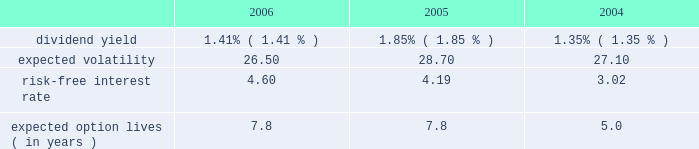For the year ended december 31 , 2005 , we realized net losses of $ 1 million on sales of available-for- sale securities .
Unrealized gains of $ 1 million were included in other comprehensive income at december 31 , 2004 , net of deferred taxes of less than $ 1 million , related to these sales .
For the year ended december 31 , 2004 , we realized net gains of $ 26 million on sales of available-for- sale securities .
Unrealized gains of $ 11 million were included in other comprehensive income at december 31 , 2003 , net of deferred taxes of $ 7 million , related to these sales .
Note 13 .
Equity-based compensation the 2006 equity incentive plan was approved by shareholders in april 2006 , and 20000000 shares of common stock were approved for issuance for stock and stock-based awards , including stock options , stock appreciation rights , restricted stock , deferred stock and performance awards .
In addition , up to 8000000 shares from our 1997 equity incentive plan , that were available to issue or become available due to cancellations and forfeitures , may be awarded under the 2006 plan .
The 1997 plan expired on december 18 , 2006 .
As of december 31 , 2006 , 1305420 shares from the 1997 plan have been added to and may be awarded from the 2006 plan .
As of december 31 , 2006 , 106045 awards have been made under the 2006 plan .
We have stock options outstanding from previous plans , including the 1997 plan , under which no further grants can be made .
The exercise price of non-qualified and incentive stock options and stock appreciation rights may not be less than the fair value of such shares at the date of grant .
Stock options and stock appreciation rights issued under the 2006 plan and the prior 1997 plan generally vest over four years and expire no later than ten years from the date of grant .
For restricted stock awards issued under the 2006 plan and the prior 1997 plan , stock certificates are issued at the time of grant and recipients have dividend and voting rights .
In general , these grants vest over three years .
For deferred stock awards issued under the 2006 plan and the prior 1997 plan , no stock is issued at the time of grant .
Generally , these grants vest over two- , three- or four-year periods .
Performance awards granted under the 2006 equity incentive plan and the prior 1997 plan are earned over a performance period based on achievement of goals , generally over two- to three- year periods .
Payment for performance awards is made in shares of our common stock or in cash equal to the fair market value of our common stock , based on certain financial ratios after the conclusion of each performance period .
We record compensation expense , equal to the estimated fair value of the options on the grant date , on a straight-line basis over the options 2019 vesting period .
We use a black-scholes option-pricing model to estimate the fair value of the options granted .
The weighted-average assumptions used in connection with the option-pricing model were as follows for the years indicated. .
Compensation expense related to stock options , stock appreciation rights , restricted stock awards , deferred stock awards and performance awards , which we record as a component of salaries and employee benefits expense in our consolidated statement of income , was $ 208 million , $ 110 million and $ 74 million for the years ended december 31 , 2006 , 2005 and 2004 , respectively .
The related total income tax benefit recorded in our consolidated statement of income was $ 83 million , $ 44 million and $ 30 million for 2006 , 2005 and 2004 , respectively .
Seq 87 copyarea : 38 .
X 54 .
Trimsize : 8.25 x 10.75 typeset state street corporation serverprocess c:\\fc\\delivery_1024177\\2771-1-do_p.pdf chksum : 0 cycle 1merrill corporation 07-2771-1 thu mar 01 17:11:13 2007 ( v 2.247w--stp1pae18 ) .
What is the growth rate in the risk-free interest rate from 2004 to 2005? 
Computations: ((4.19 - 3.02) / 3.02)
Answer: 0.38742. 